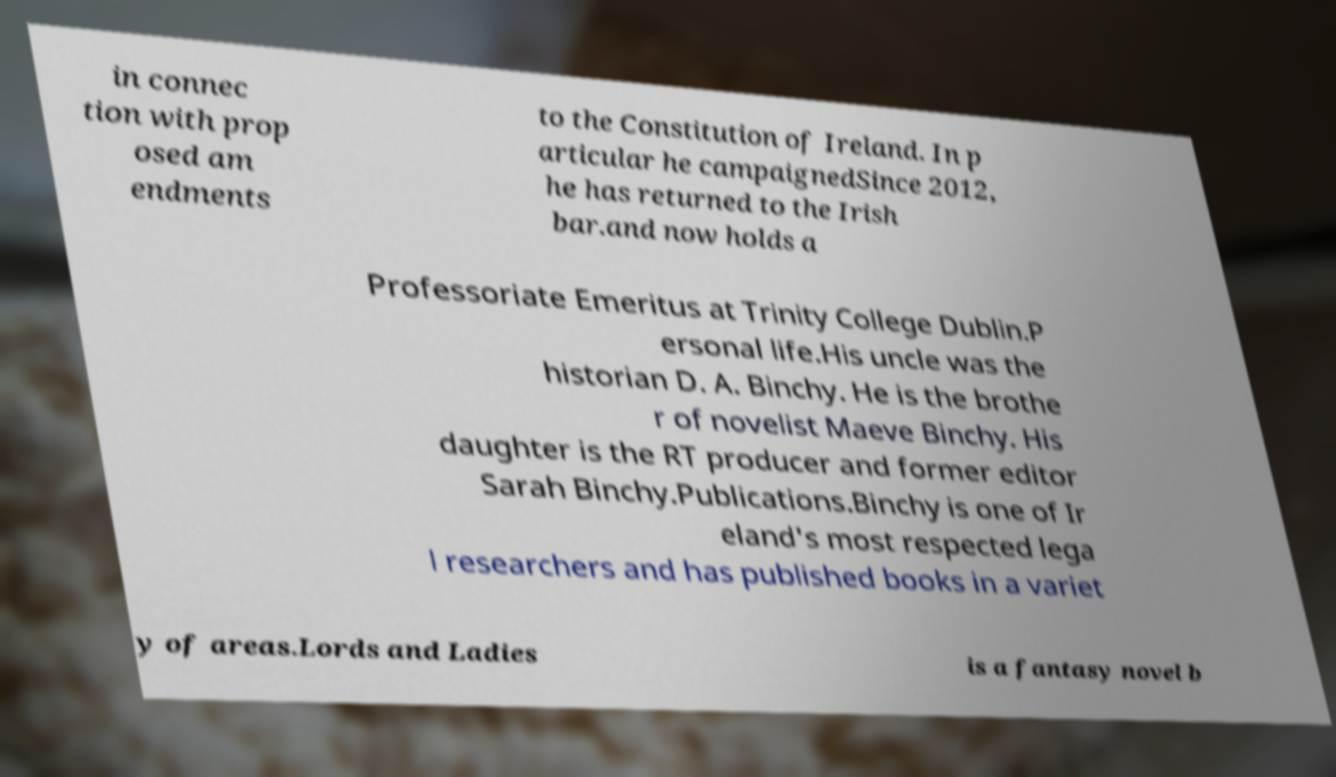Can you read and provide the text displayed in the image?This photo seems to have some interesting text. Can you extract and type it out for me? in connec tion with prop osed am endments to the Constitution of Ireland. In p articular he campaignedSince 2012, he has returned to the Irish bar.and now holds a Professoriate Emeritus at Trinity College Dublin.P ersonal life.His uncle was the historian D. A. Binchy. He is the brothe r of novelist Maeve Binchy. His daughter is the RT producer and former editor Sarah Binchy.Publications.Binchy is one of Ir eland's most respected lega l researchers and has published books in a variet y of areas.Lords and Ladies is a fantasy novel b 